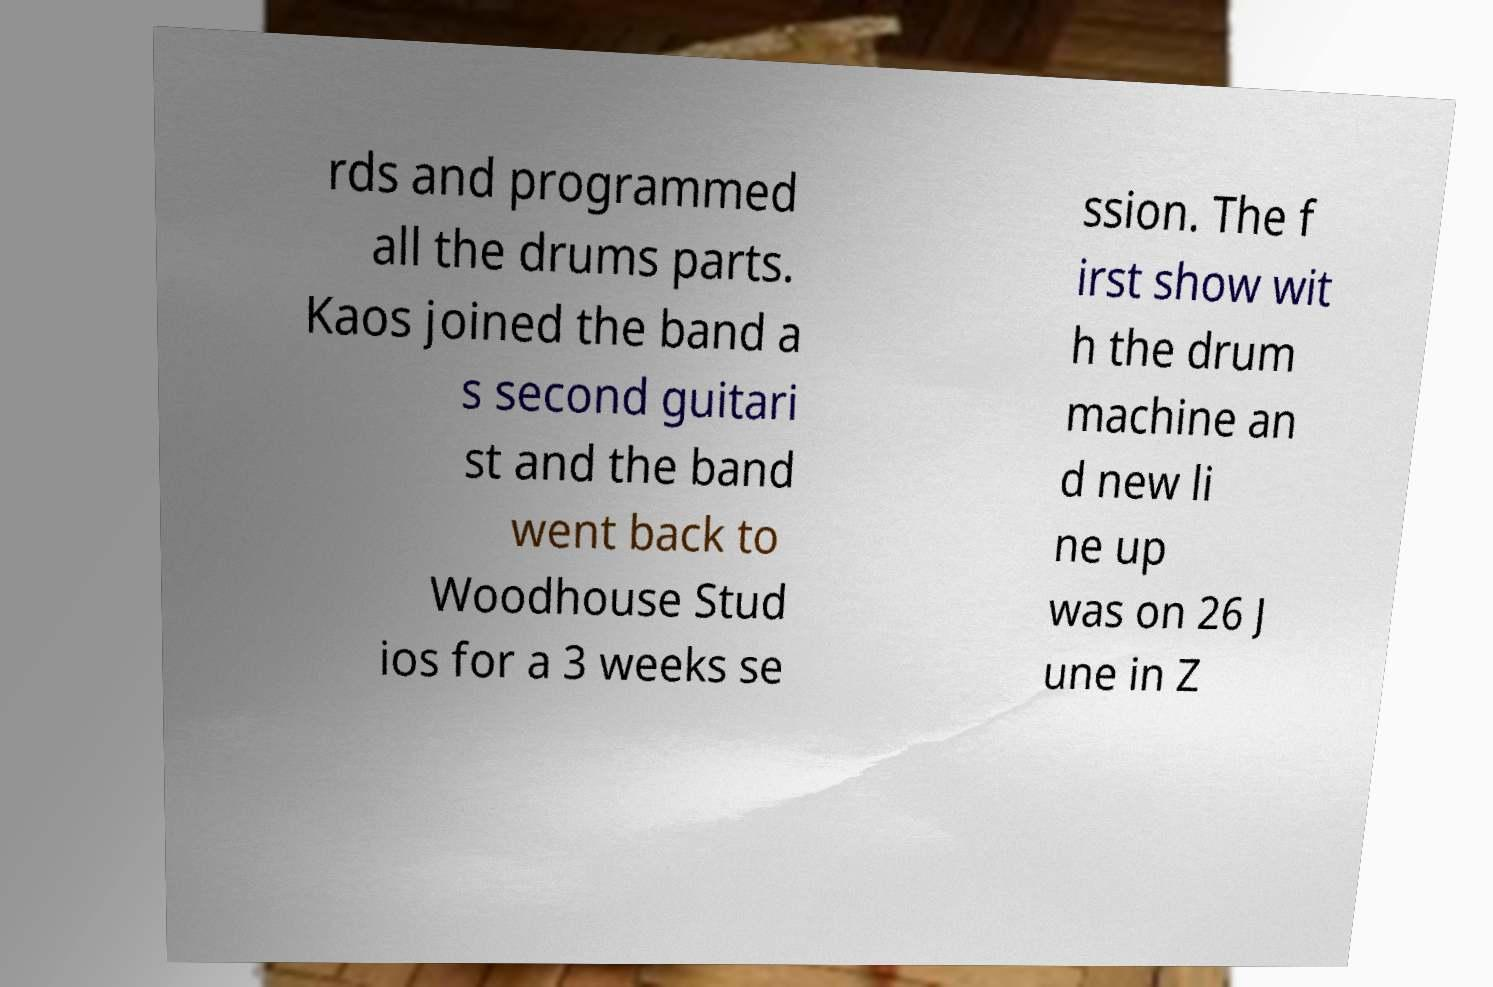I need the written content from this picture converted into text. Can you do that? rds and programmed all the drums parts. Kaos joined the band a s second guitari st and the band went back to Woodhouse Stud ios for a 3 weeks se ssion. The f irst show wit h the drum machine an d new li ne up was on 26 J une in Z 